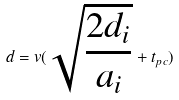<formula> <loc_0><loc_0><loc_500><loc_500>d = v ( \sqrt { \frac { 2 d _ { i } } { a _ { i } } } + t _ { p c } )</formula> 